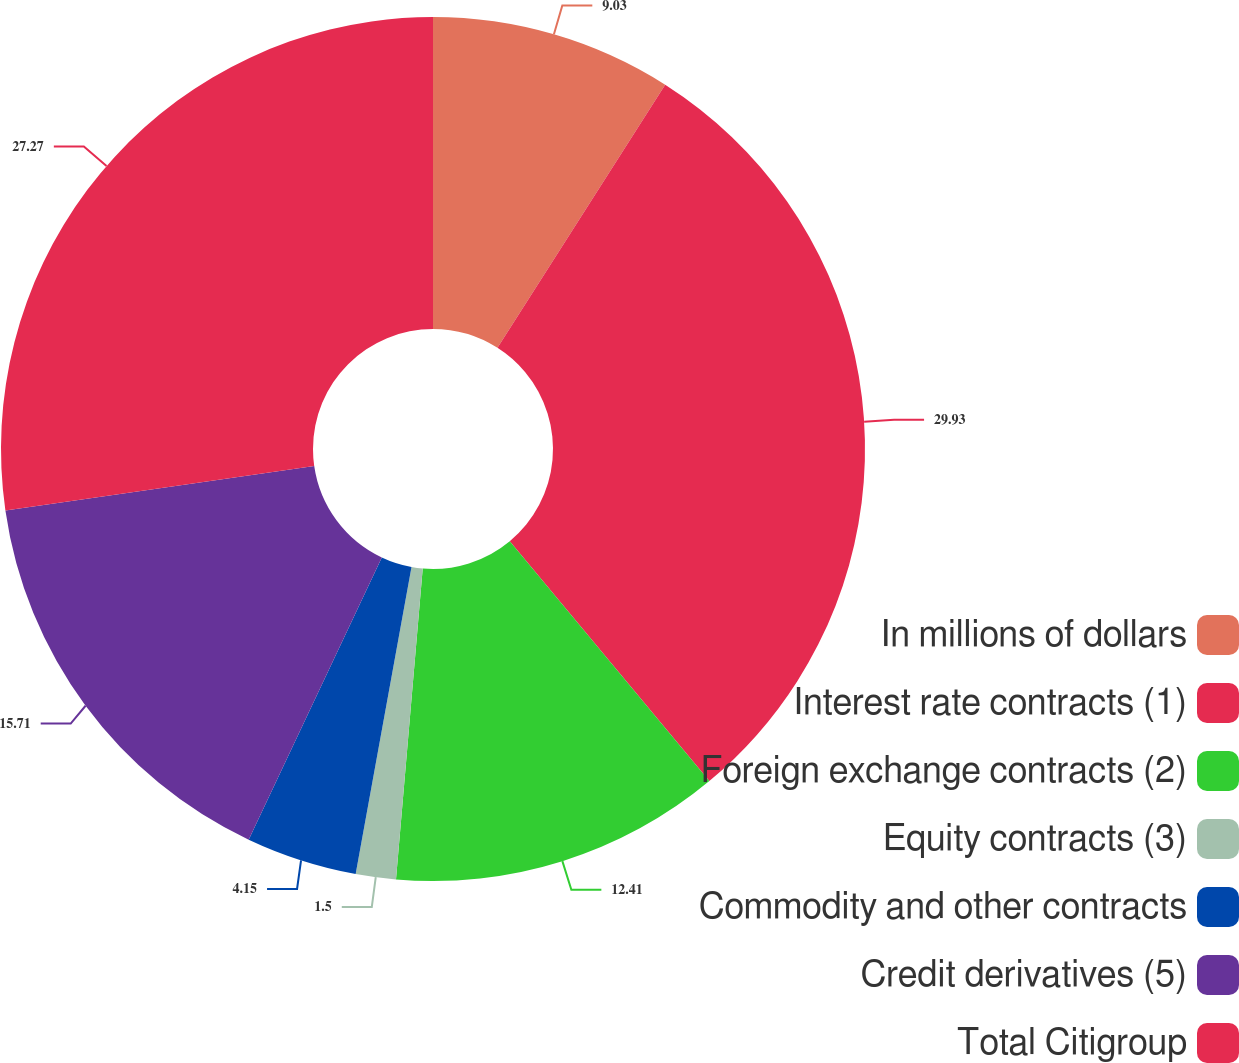<chart> <loc_0><loc_0><loc_500><loc_500><pie_chart><fcel>In millions of dollars<fcel>Interest rate contracts (1)<fcel>Foreign exchange contracts (2)<fcel>Equity contracts (3)<fcel>Commodity and other contracts<fcel>Credit derivatives (5)<fcel>Total Citigroup<nl><fcel>9.03%<fcel>29.92%<fcel>12.41%<fcel>1.5%<fcel>4.15%<fcel>15.71%<fcel>27.27%<nl></chart> 